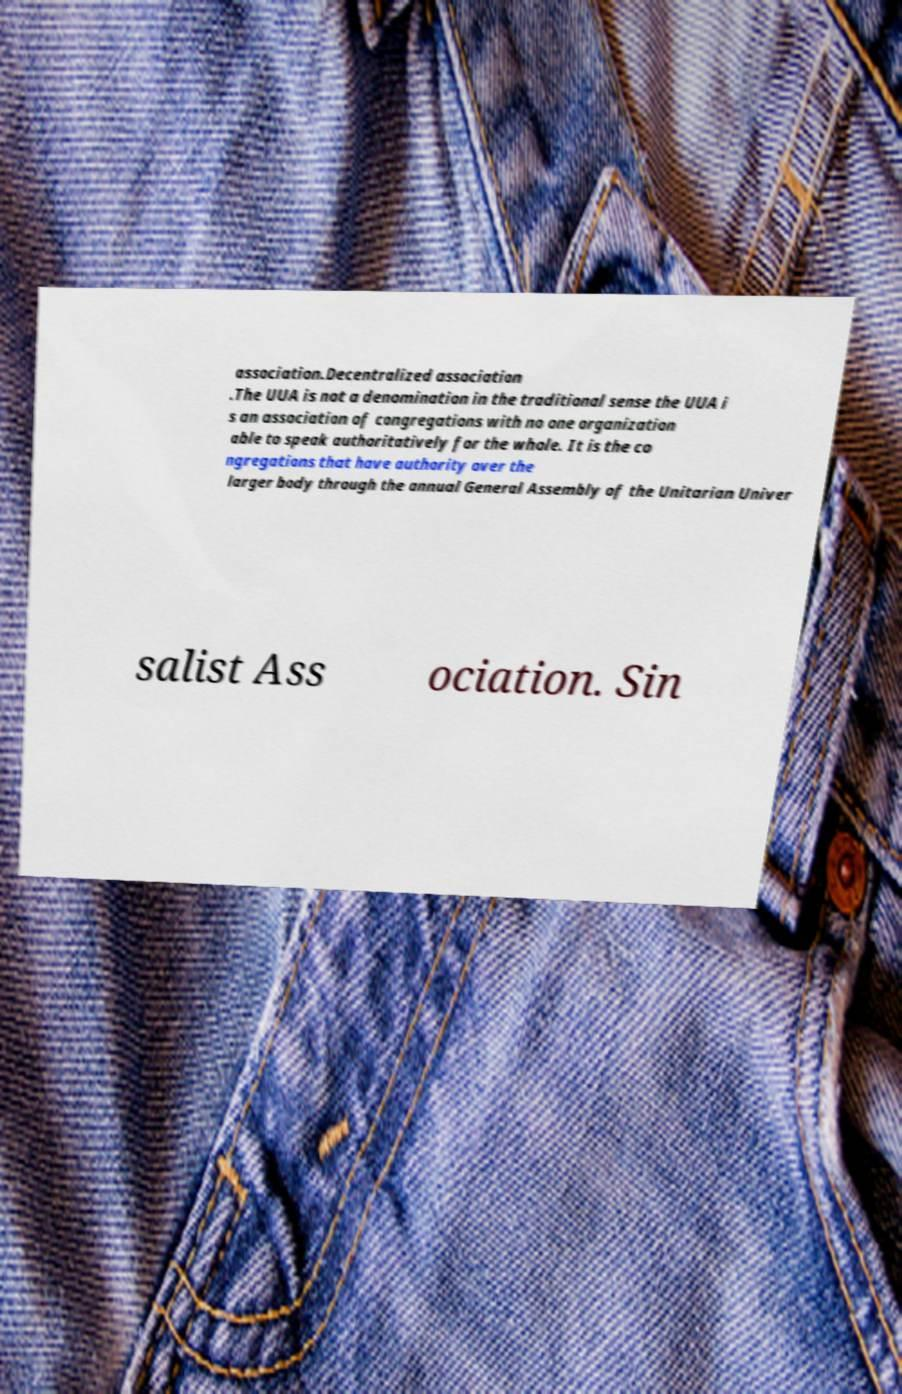Could you extract and type out the text from this image? association.Decentralized association .The UUA is not a denomination in the traditional sense the UUA i s an association of congregations with no one organization able to speak authoritatively for the whole. It is the co ngregations that have authority over the larger body through the annual General Assembly of the Unitarian Univer salist Ass ociation. Sin 